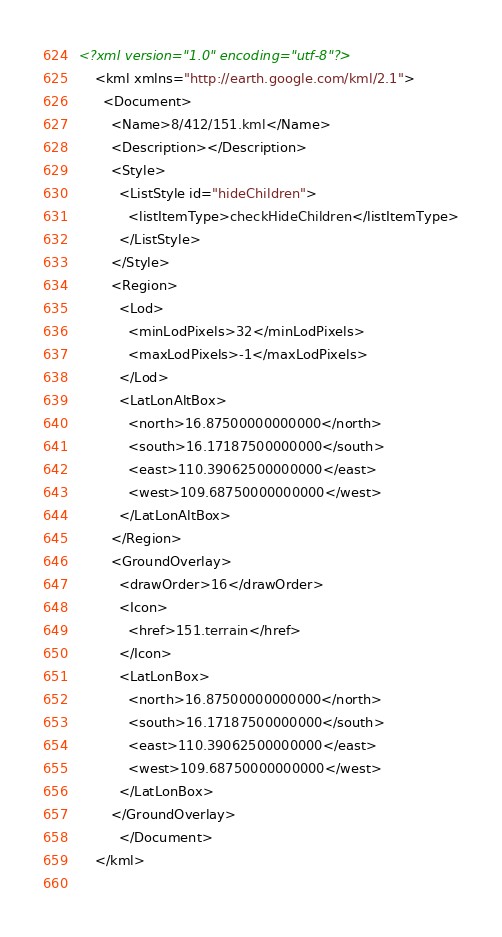Convert code to text. <code><loc_0><loc_0><loc_500><loc_500><_XML_><?xml version="1.0" encoding="utf-8"?>
	<kml xmlns="http://earth.google.com/kml/2.1">
	  <Document>
	    <Name>8/412/151.kml</Name>
	    <Description></Description>
	    <Style>
	      <ListStyle id="hideChildren">
	        <listItemType>checkHideChildren</listItemType>
	      </ListStyle>
	    </Style>
	    <Region>
	      <Lod>
	        <minLodPixels>32</minLodPixels>
	        <maxLodPixels>-1</maxLodPixels>
	      </Lod>
	      <LatLonAltBox>
	        <north>16.87500000000000</north>
	        <south>16.17187500000000</south>
	        <east>110.39062500000000</east>
	        <west>109.68750000000000</west>
	      </LatLonAltBox>
	    </Region>
	    <GroundOverlay>
	      <drawOrder>16</drawOrder>
	      <Icon>
	        <href>151.terrain</href>
	      </Icon>
	      <LatLonBox>
	        <north>16.87500000000000</north>
	        <south>16.17187500000000</south>
	        <east>110.39062500000000</east>
	        <west>109.68750000000000</west>
	      </LatLonBox>
	    </GroundOverlay>
		  </Document>
	</kml>
	</code> 